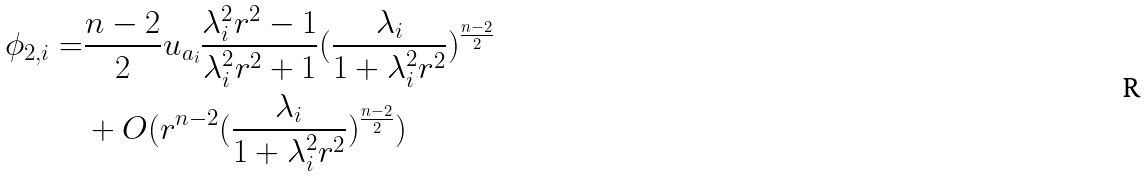<formula> <loc_0><loc_0><loc_500><loc_500>\phi _ { 2 , i } = & \frac { n - 2 } { 2 } u _ { a _ { i } } \frac { \lambda _ { i } ^ { 2 } r ^ { 2 } - 1 } { \lambda _ { i } ^ { 2 } r ^ { 2 } + 1 } ( \frac { \lambda _ { i } } { 1 + \lambda _ { i } ^ { 2 } r ^ { 2 } } ) ^ { \frac { n - 2 } { 2 } } \\ & + O ( r ^ { n - 2 } ( \frac { \lambda _ { i } } { 1 + \lambda _ { i } ^ { 2 } r ^ { 2 } } ) ^ { \frac { n - 2 } { 2 } } )</formula> 